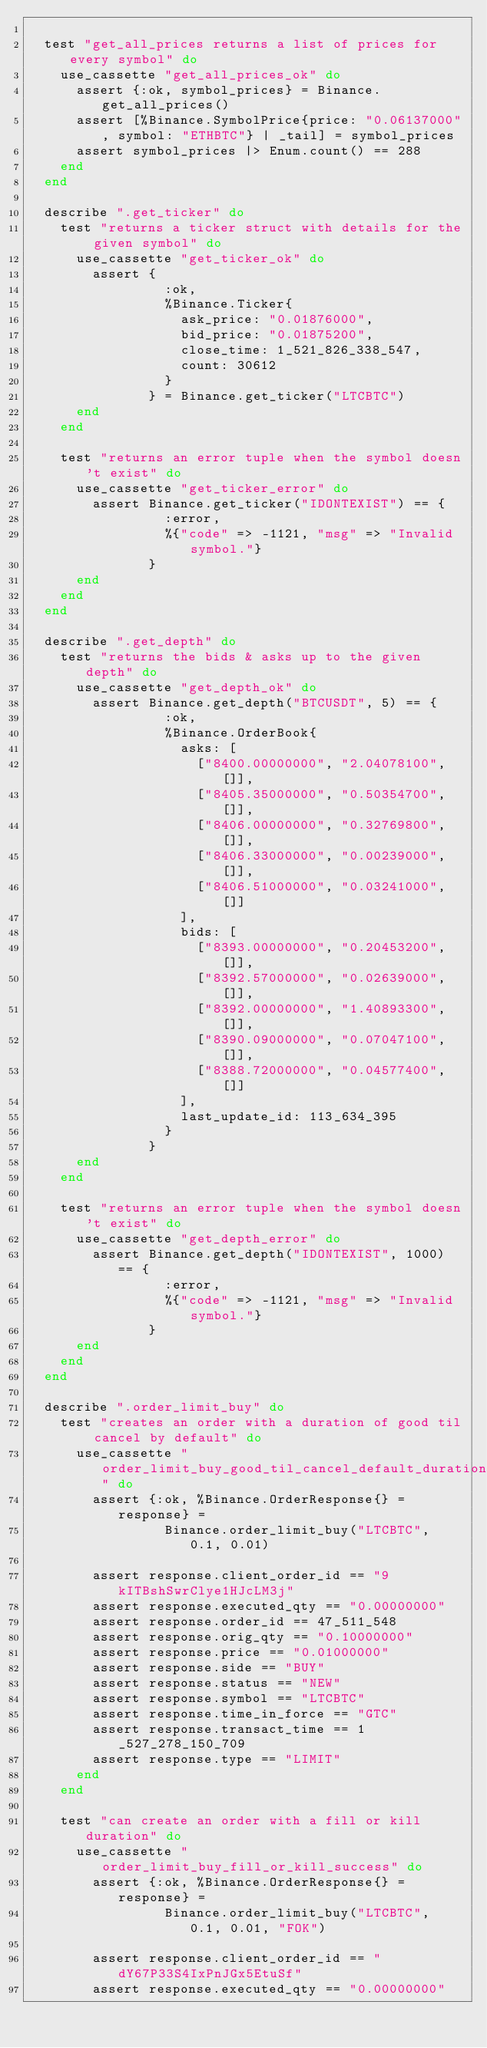<code> <loc_0><loc_0><loc_500><loc_500><_Elixir_>
  test "get_all_prices returns a list of prices for every symbol" do
    use_cassette "get_all_prices_ok" do
      assert {:ok, symbol_prices} = Binance.get_all_prices()
      assert [%Binance.SymbolPrice{price: "0.06137000", symbol: "ETHBTC"} | _tail] = symbol_prices
      assert symbol_prices |> Enum.count() == 288
    end
  end

  describe ".get_ticker" do
    test "returns a ticker struct with details for the given symbol" do
      use_cassette "get_ticker_ok" do
        assert {
                 :ok,
                 %Binance.Ticker{
                   ask_price: "0.01876000",
                   bid_price: "0.01875200",
                   close_time: 1_521_826_338_547,
                   count: 30612
                 }
               } = Binance.get_ticker("LTCBTC")
      end
    end

    test "returns an error tuple when the symbol doesn't exist" do
      use_cassette "get_ticker_error" do
        assert Binance.get_ticker("IDONTEXIST") == {
                 :error,
                 %{"code" => -1121, "msg" => "Invalid symbol."}
               }
      end
    end
  end

  describe ".get_depth" do
    test "returns the bids & asks up to the given depth" do
      use_cassette "get_depth_ok" do
        assert Binance.get_depth("BTCUSDT", 5) == {
                 :ok,
                 %Binance.OrderBook{
                   asks: [
                     ["8400.00000000", "2.04078100", []],
                     ["8405.35000000", "0.50354700", []],
                     ["8406.00000000", "0.32769800", []],
                     ["8406.33000000", "0.00239000", []],
                     ["8406.51000000", "0.03241000", []]
                   ],
                   bids: [
                     ["8393.00000000", "0.20453200", []],
                     ["8392.57000000", "0.02639000", []],
                     ["8392.00000000", "1.40893300", []],
                     ["8390.09000000", "0.07047100", []],
                     ["8388.72000000", "0.04577400", []]
                   ],
                   last_update_id: 113_634_395
                 }
               }
      end
    end

    test "returns an error tuple when the symbol doesn't exist" do
      use_cassette "get_depth_error" do
        assert Binance.get_depth("IDONTEXIST", 1000) == {
                 :error,
                 %{"code" => -1121, "msg" => "Invalid symbol."}
               }
      end
    end
  end

  describe ".order_limit_buy" do
    test "creates an order with a duration of good til cancel by default" do
      use_cassette "order_limit_buy_good_til_cancel_default_duration_success" do
        assert {:ok, %Binance.OrderResponse{} = response} =
                 Binance.order_limit_buy("LTCBTC", 0.1, 0.01)

        assert response.client_order_id == "9kITBshSwrClye1HJcLM3j"
        assert response.executed_qty == "0.00000000"
        assert response.order_id == 47_511_548
        assert response.orig_qty == "0.10000000"
        assert response.price == "0.01000000"
        assert response.side == "BUY"
        assert response.status == "NEW"
        assert response.symbol == "LTCBTC"
        assert response.time_in_force == "GTC"
        assert response.transact_time == 1_527_278_150_709
        assert response.type == "LIMIT"
      end
    end

    test "can create an order with a fill or kill duration" do
      use_cassette "order_limit_buy_fill_or_kill_success" do
        assert {:ok, %Binance.OrderResponse{} = response} =
                 Binance.order_limit_buy("LTCBTC", 0.1, 0.01, "FOK")

        assert response.client_order_id == "dY67P33S4IxPnJGx5EtuSf"
        assert response.executed_qty == "0.00000000"</code> 